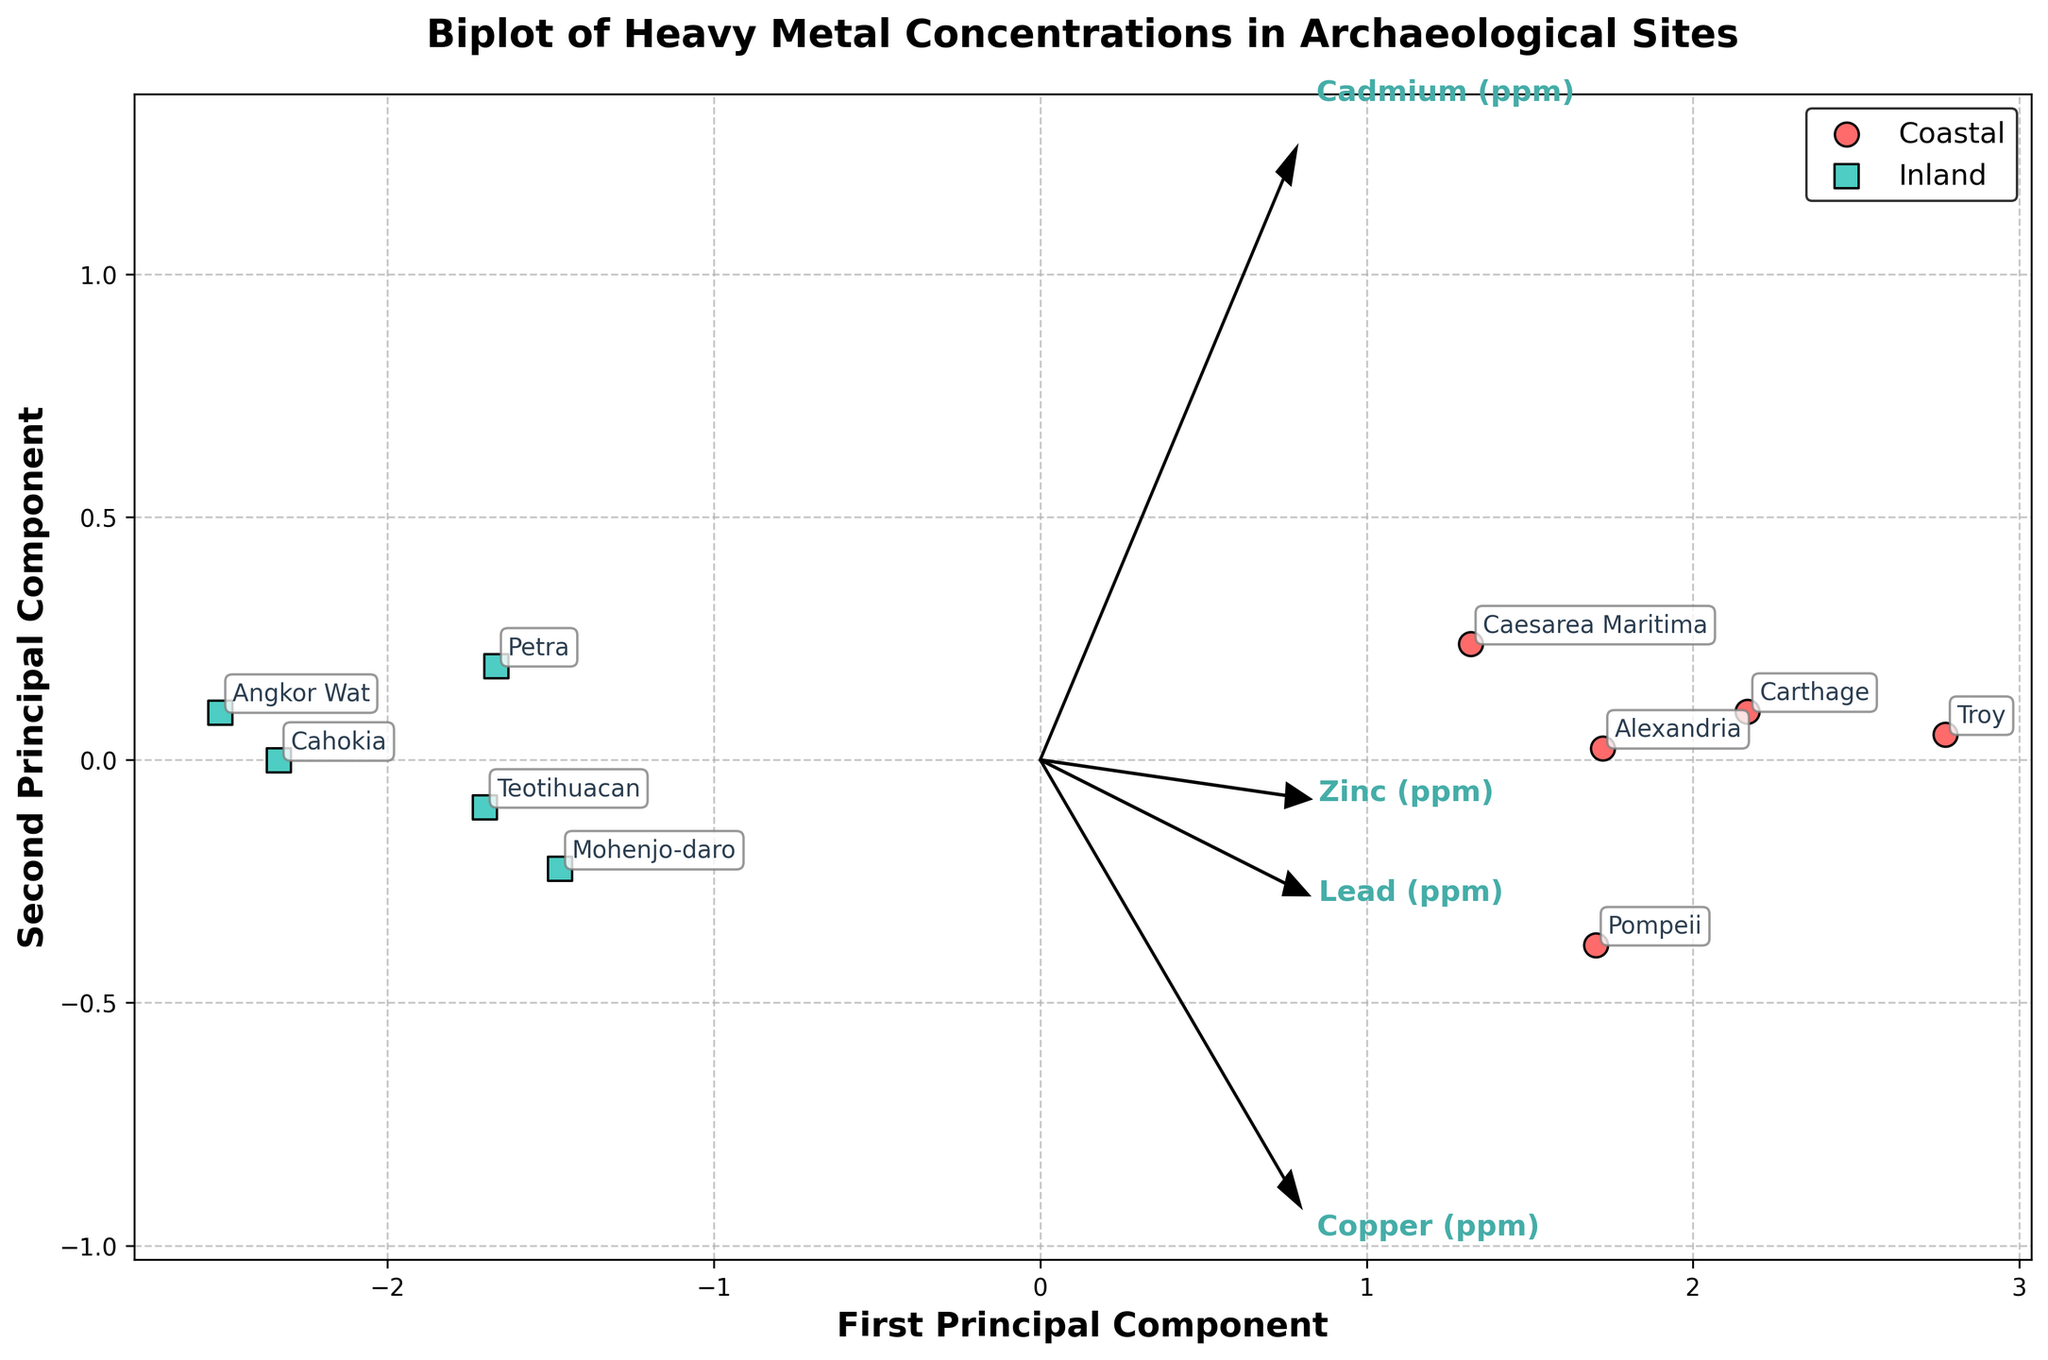What's the title of the biplot figure? The title is located above the figure, indicating what the plot represents.
Answer: Biplot of Heavy Metal Concentrations in Archaeological Sites How many data points represent coastal sites? Observe the number of circles marked as coastal points in the biplot.
Answer: 5 Which axis is labeled 'First Principal Component'? Look at the figure and identify the axis with the label 'First Principal Component'.
Answer: X-axis Which type of site shows a greater spread along the Second Principal Component? Compare the spread of coastal and inland sites along the y-axis. Inland shows a wider spread in the vertical direction.
Answer: Inland Which site is located closest to the origin? Find the data point that is nearest to the (0, 0) coordinates on the biplot.
Answer: Petra What is the direction of the Zinc vector in the plot? Observe the arrow corresponding to Zinc; the direction indicates its contribution.
Answer: Positively along the first principal component, slightly positive along the second Which group has more data points, coastal or inland? Count the number of coastal and inland sites based on the plot's legend.
Answer: Both have equal data points Are there any vectors pointing in the negative direction of the Second Principal Component? Check if any feature vectors extend into the negative y-axis of the plot.
Answer: No Which site has the widest spread on the First Principal Component? Identify the site with the furthest horizontal distance from the origin.
Answer: Troy Which sites have Cadmium concentrations represented by a positive First Principal Component? Look at the positioning of the Cadmium vector and see which sites lie on this vector's positive side on the X-axis.
Answer: Troy, Carthage, Pompeii, Alexandria, Caesarea Maritima 